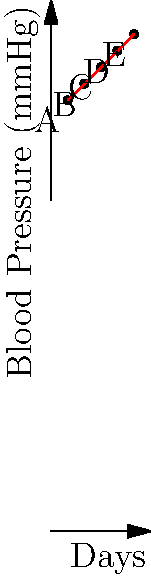A nurse practitioner is monitoring your blood pressure remotely over a 25-day period. The scatter plot shows your systolic blood pressure readings taken every 5 days. What is the approximate rate of increase in blood pressure per day based on the trend line? To find the rate of increase in blood pressure per day, we need to:

1. Identify the start and end points of the trend line:
   Start point (A): (5, 130)
   End point (E): (25, 150)

2. Calculate the change in blood pressure (y-axis):
   $\Delta y = 150 - 130 = 20$ mmHg

3. Calculate the change in days (x-axis):
   $\Delta x = 25 - 5 = 20$ days

4. Use the slope formula to find the rate of increase:
   Rate = $\frac{\Delta y}{\Delta x} = \frac{20 \text{ mmHg}}{20 \text{ days}} = 1 \text{ mmHg/day}$

Therefore, the blood pressure is increasing at a rate of approximately 1 mmHg per day.
Answer: 1 mmHg/day 